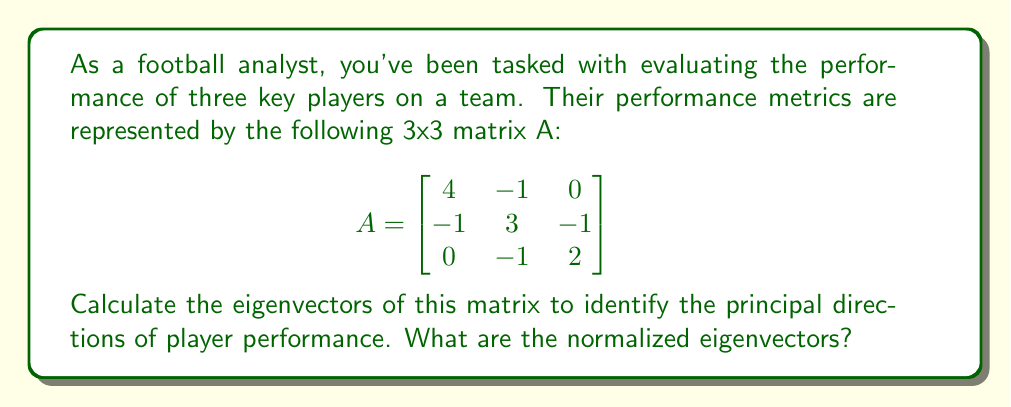Give your solution to this math problem. To find the eigenvectors, we'll follow these steps:

1) First, we need to find the eigenvalues by solving the characteristic equation:
   $det(A - \lambda I) = 0$

2) Expand the determinant:
   $$\begin{vmatrix}
   4-\lambda & -1 & 0 \\
   -1 & 3-\lambda & -1 \\
   0 & -1 & 2-\lambda
   \end{vmatrix} = 0$$

3) This gives us the characteristic polynomial:
   $(4-\lambda)(3-\lambda)(2-\lambda) - (4-\lambda) - (2-\lambda) = 0$
   $\lambda^3 - 9\lambda^2 + 24\lambda - 18 = 0$

4) Factoring this polynomial:
   $(\lambda - 1)(\lambda - 2)(\lambda - 6) = 0$

5) So, the eigenvalues are $\lambda_1 = 1$, $\lambda_2 = 2$, and $\lambda_3 = 6$

6) For each eigenvalue, we solve $(A - \lambda I)v = 0$ to find the corresponding eigenvector:

   For $\lambda_1 = 1$:
   $$\begin{bmatrix}
   3 & -1 & 0 \\
   -1 & 2 & -1 \\
   0 & -1 & 1
   \end{bmatrix}\begin{bmatrix}
   v_1 \\ v_2 \\ v_3
   \end{bmatrix} = \begin{bmatrix}
   0 \\ 0 \\ 0
   \end{bmatrix}$$

   Solving this gives us $v_1 = (1, 1, 1)^T$

   For $\lambda_2 = 2$:
   $$\begin{bmatrix}
   2 & -1 & 0 \\
   -1 & 1 & -1 \\
   0 & -1 & 0
   \end{bmatrix}\begin{bmatrix}
   v_1 \\ v_2 \\ v_3
   \end{bmatrix} = \begin{bmatrix}
   0 \\ 0 \\ 0
   \end{bmatrix}$$

   Solving this gives us $v_2 = (1, 2, 2)^T$

   For $\lambda_3 = 6$:
   $$\begin{bmatrix}
   -2 & -1 & 0 \\
   -1 & -3 & -1 \\
   0 & -1 & -4
   \end{bmatrix}\begin{bmatrix}
   v_1 \\ v_2 \\ v_3
   \end{bmatrix} = \begin{bmatrix}
   0 \\ 0 \\ 0
   \end{bmatrix}$$

   Solving this gives us $v_3 = (2, 2, 1)^T$

7) Normalize each eigenvector by dividing by its magnitude:

   $\|v_1\| = \sqrt{1^2 + 1^2 + 1^2} = \sqrt{3}$
   $\|v_2\| = \sqrt{1^2 + 2^2 + 2^2} = 3$
   $\|v_3\| = \sqrt{2^2 + 2^2 + 1^2} = 3$

   Normalized vectors:
   $v_1 = (\frac{1}{\sqrt{3}}, \frac{1}{\sqrt{3}}, \frac{1}{\sqrt{3}})^T$
   $v_2 = (\frac{1}{3}, \frac{2}{3}, \frac{2}{3})^T$
   $v_3 = (\frac{2}{3}, \frac{2}{3}, \frac{1}{3})^T$
Answer: $v_1 = (\frac{1}{\sqrt{3}}, \frac{1}{\sqrt{3}}, \frac{1}{\sqrt{3}})^T$, $v_2 = (\frac{1}{3}, \frac{2}{3}, \frac{2}{3})^T$, $v_3 = (\frac{2}{3}, \frac{2}{3}, \frac{1}{3})^T$ 